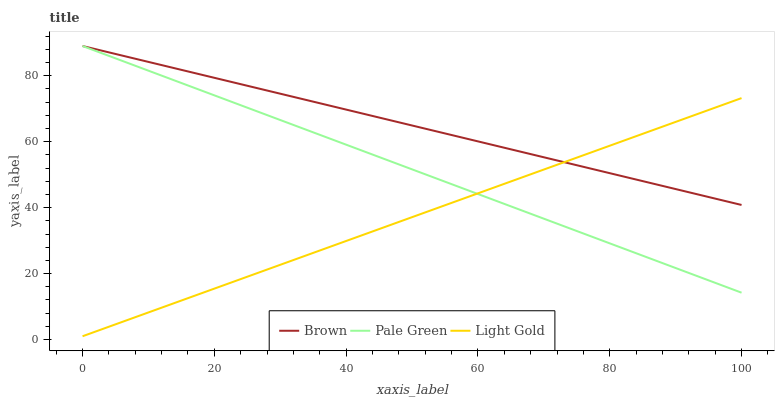Does Light Gold have the minimum area under the curve?
Answer yes or no. Yes. Does Brown have the maximum area under the curve?
Answer yes or no. Yes. Does Pale Green have the minimum area under the curve?
Answer yes or no. No. Does Pale Green have the maximum area under the curve?
Answer yes or no. No. Is Pale Green the smoothest?
Answer yes or no. Yes. Is Brown the roughest?
Answer yes or no. Yes. Is Light Gold the smoothest?
Answer yes or no. No. Is Light Gold the roughest?
Answer yes or no. No. Does Light Gold have the lowest value?
Answer yes or no. Yes. Does Pale Green have the lowest value?
Answer yes or no. No. Does Pale Green have the highest value?
Answer yes or no. Yes. Does Light Gold have the highest value?
Answer yes or no. No. Does Light Gold intersect Brown?
Answer yes or no. Yes. Is Light Gold less than Brown?
Answer yes or no. No. Is Light Gold greater than Brown?
Answer yes or no. No. 